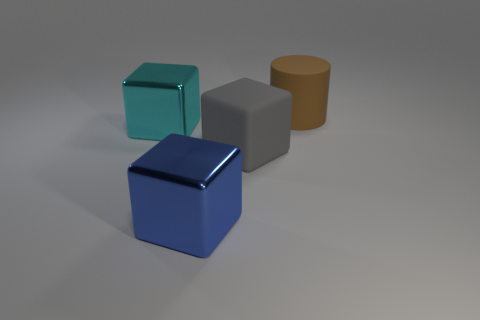There is a metallic object that is behind the big blue thing; does it have the same color as the big cylinder?
Ensure brevity in your answer.  No. The cyan shiny object that is the same shape as the big gray object is what size?
Keep it short and to the point. Large. Is there anything else that is made of the same material as the big brown cylinder?
Give a very brief answer. Yes. Is there a blue object that is on the right side of the brown rubber cylinder that is on the right side of the thing that is in front of the gray cube?
Make the answer very short. No. What is the cube that is on the left side of the blue shiny cube made of?
Your response must be concise. Metal. How many large objects are either cubes or cyan objects?
Offer a very short reply. 3. Does the rubber thing on the left side of the brown matte thing have the same size as the big brown cylinder?
Offer a terse response. Yes. What number of other things are the same color as the large rubber cube?
Offer a terse response. 0. What is the material of the blue cube?
Your answer should be very brief. Metal. There is a large cube that is to the left of the big gray thing and in front of the cyan metallic block; what is its material?
Make the answer very short. Metal. 